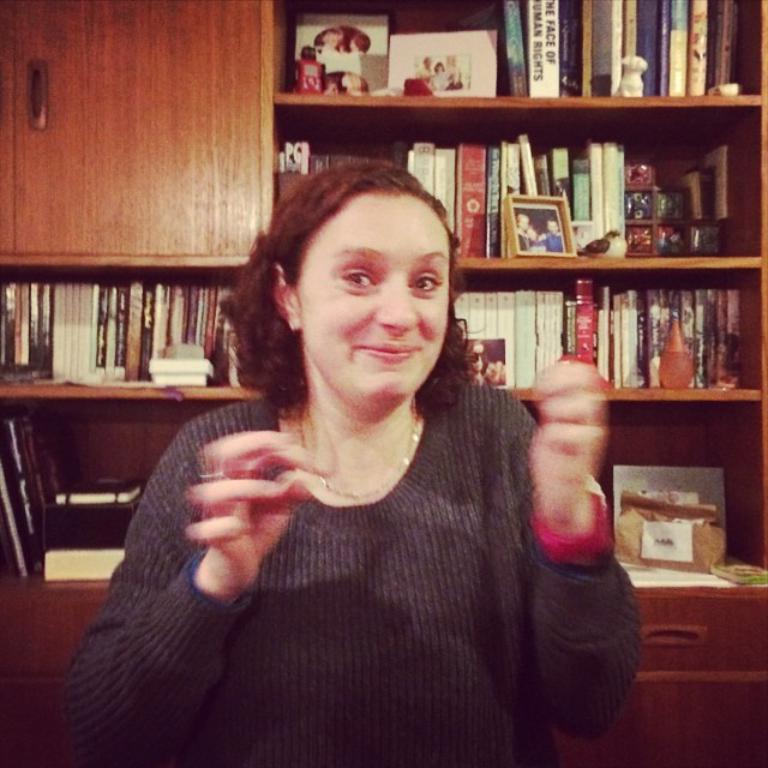Please provide a concise description of this image. This image consists of a woman. In the background, we can see the books kept in the racks. On the top left, there is a cupboard. At the bottom, there are drawers. 